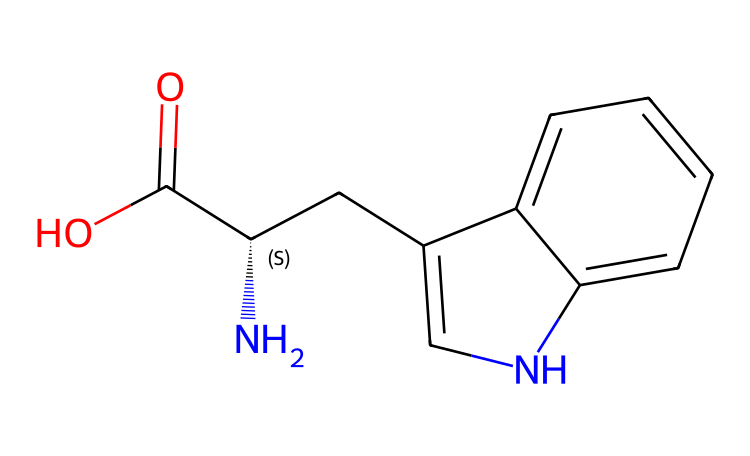What is the molecular formula of L-tryptophan? By interpreting the SMILES representation, we can count the number of each type of atom present: there are 11 carbons, 12 hydrogens, 1 nitrogen, and 2 oxygens, leading to the molecular formula C11H12N2O2.
Answer: C11H12N2O2 How many chiral centers are in L-tryptophan? The SMILES structure indicates a stereocenter at the carbon marked with the chirality symbol (C@@H), showing that there is one chiral center in the compound.
Answer: 1 What type of functional groups are present in L-tryptophan? Looking at the structure, we can identify the presence of a carboxylic acid group (–COOH) and an amino group (–NH2), making it an amino acid.
Answer: amino and carboxylic acid What is the significance of the 'C@@H' in the structure? The 'C@@H' notation denotes a chiral carbon center, which is crucial for the stereochemical properties of the molecule. This affects how L-tryptophan interacts biologically with enzymes and receptors.
Answer: chiral center Which heteroatom is found in L-tryptophan? Analyzing the SMILES representation, we see one nitrogen atom in the indole ring, which makes it a heteroatom that contributes to the unique properties of this amino acid.
Answer: nitrogen What makes L-tryptophan an essential amino acid? L-tryptophan cannot be synthesized by the human body and must be obtained through the diet, which classifies it as an essential amino acid, necessary for protein synthesis and neurotransmitter production.
Answer: dietary necessity 